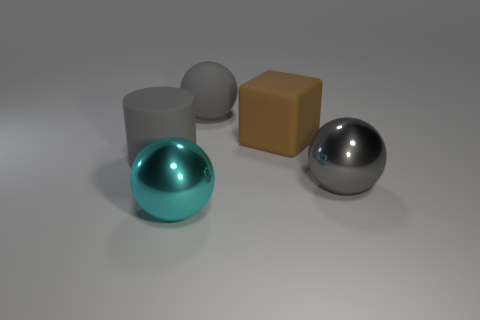Is there anything else of the same color as the large matte cylinder?
Your response must be concise. Yes. What is the shape of the matte object that is the same color as the matte sphere?
Your response must be concise. Cylinder. Does the rubber object behind the rubber block have the same color as the cylinder?
Your answer should be very brief. Yes. How many gray metallic spheres have the same size as the brown block?
Provide a short and direct response. 1. The brown thing that is made of the same material as the gray cylinder is what shape?
Your response must be concise. Cube. Is there a matte ball of the same color as the cylinder?
Your answer should be compact. Yes. What is the material of the cyan object?
Provide a short and direct response. Metal. What number of things are matte blocks or large metallic spheres?
Give a very brief answer. 3. How many other objects are the same material as the gray cylinder?
Make the answer very short. 2. Is there a sphere in front of the gray ball that is to the left of the brown matte object?
Provide a short and direct response. Yes. 